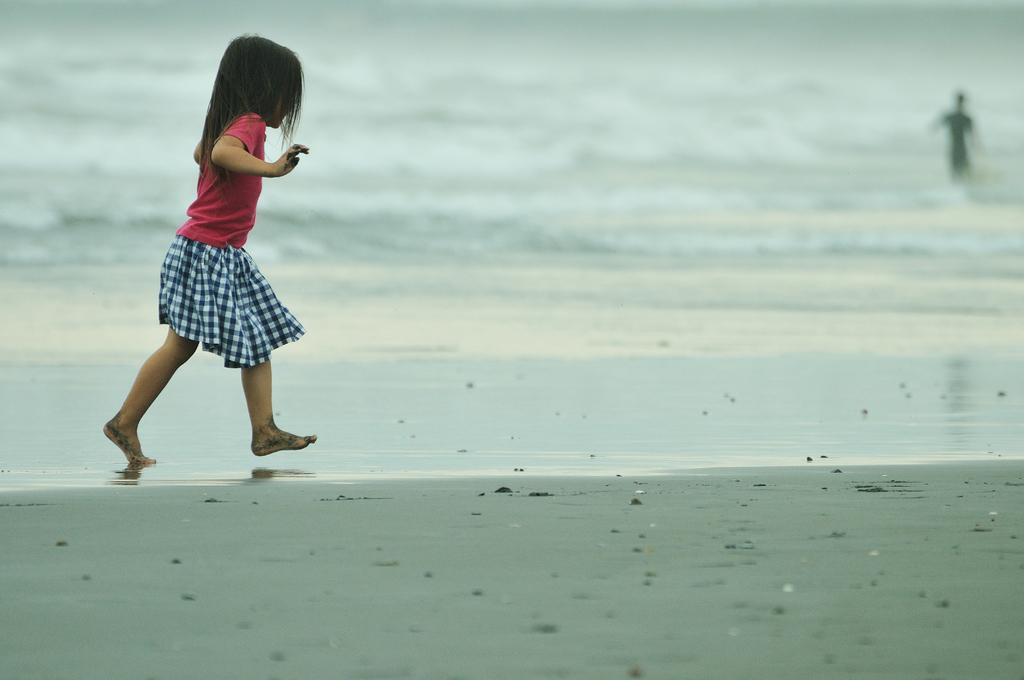What is the girl in the image doing? The girl is walking in the image. Where is the girl walking? The girl is on the beach. What else can be seen on the beach in the image? There is a man standing in the middle of the beach in the image. What type of kitty is the girl holding in the image? There is no kitty present in the image; the girl is simply walking on the beach. 